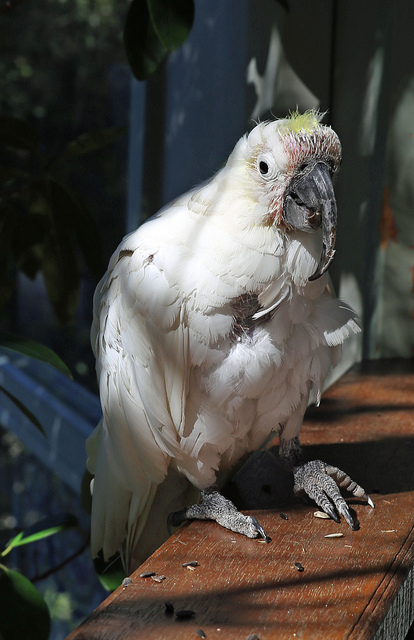<image>How many feathers does the bird have? It is impossible to determine exactly how many feathers the bird has. How many feathers does the bird have? I don't know how many feathers the bird has. It could be countless, 100, many, 3000, 489, 712, or 20000. 